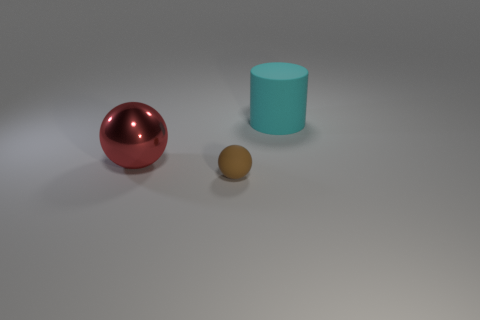There is another brown thing that is the same shape as the shiny thing; what is its size?
Keep it short and to the point. Small. There is a rubber object that is in front of the cyan thing; is there a cyan cylinder that is behind it?
Your response must be concise. Yes. Does the tiny sphere have the same color as the big cylinder?
Your answer should be very brief. No. What number of other things are there of the same shape as the metallic thing?
Offer a very short reply. 1. Are there more small brown balls that are behind the large cylinder than big cyan matte cylinders in front of the brown matte thing?
Make the answer very short. No. There is a cyan thing behind the large red thing; is its size the same as the ball in front of the red metallic thing?
Your answer should be compact. No. What is the shape of the big cyan object?
Provide a succinct answer. Cylinder. What color is the big cylinder that is made of the same material as the small ball?
Provide a succinct answer. Cyan. Is the big cyan cylinder made of the same material as the big object that is on the left side of the big rubber cylinder?
Your answer should be very brief. No. What is the color of the shiny object?
Give a very brief answer. Red. 